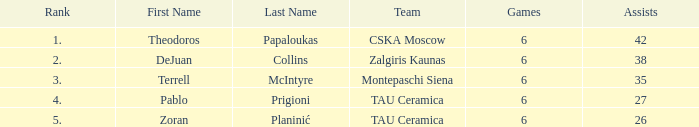What is the least number of assists among players ranked 2? 38.0. Parse the full table. {'header': ['Rank', 'First Name', 'Last Name', 'Team', 'Games', 'Assists'], 'rows': [['1.', 'Theodoros', 'Papaloukas', 'CSKA Moscow', '6', '42'], ['2.', 'DeJuan', 'Collins', 'Zalgiris Kaunas', '6', '38'], ['3.', 'Terrell', 'McIntyre', 'Montepaschi Siena', '6', '35'], ['4.', 'Pablo', 'Prigioni', 'TAU Ceramica', '6', '27'], ['5.', 'Zoran', 'Planinić', 'TAU Ceramica', '6', '26']]} 